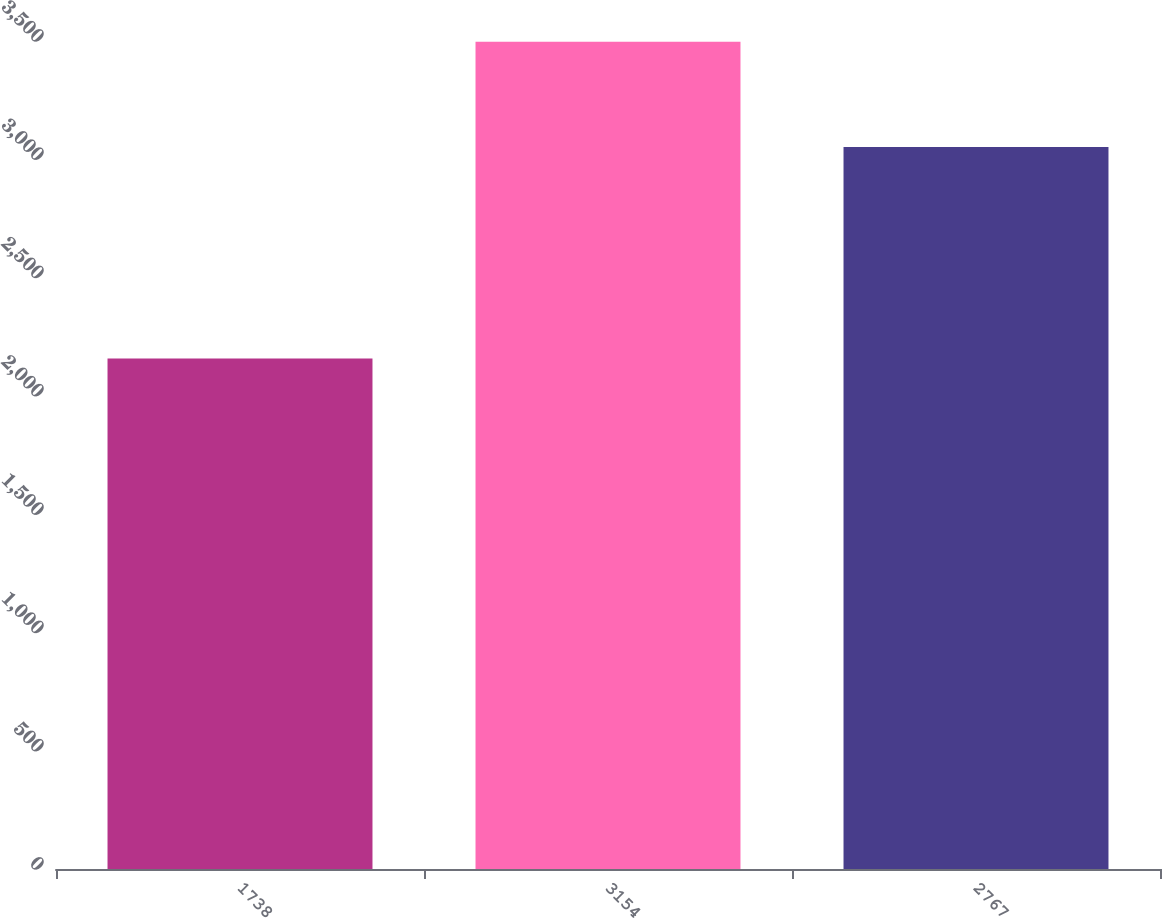Convert chart to OTSL. <chart><loc_0><loc_0><loc_500><loc_500><bar_chart><fcel>1738<fcel>3154<fcel>2767<nl><fcel>2158<fcel>3497<fcel>3052<nl></chart> 